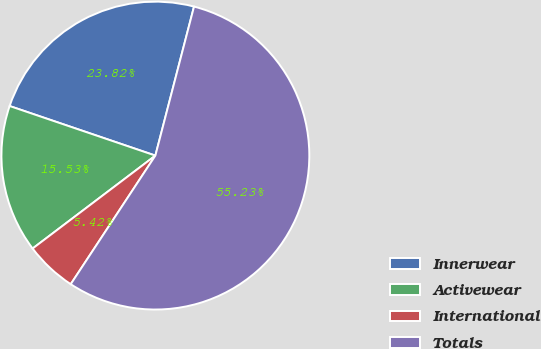<chart> <loc_0><loc_0><loc_500><loc_500><pie_chart><fcel>Innerwear<fcel>Activewear<fcel>International<fcel>Totals<nl><fcel>23.82%<fcel>15.53%<fcel>5.42%<fcel>55.22%<nl></chart> 